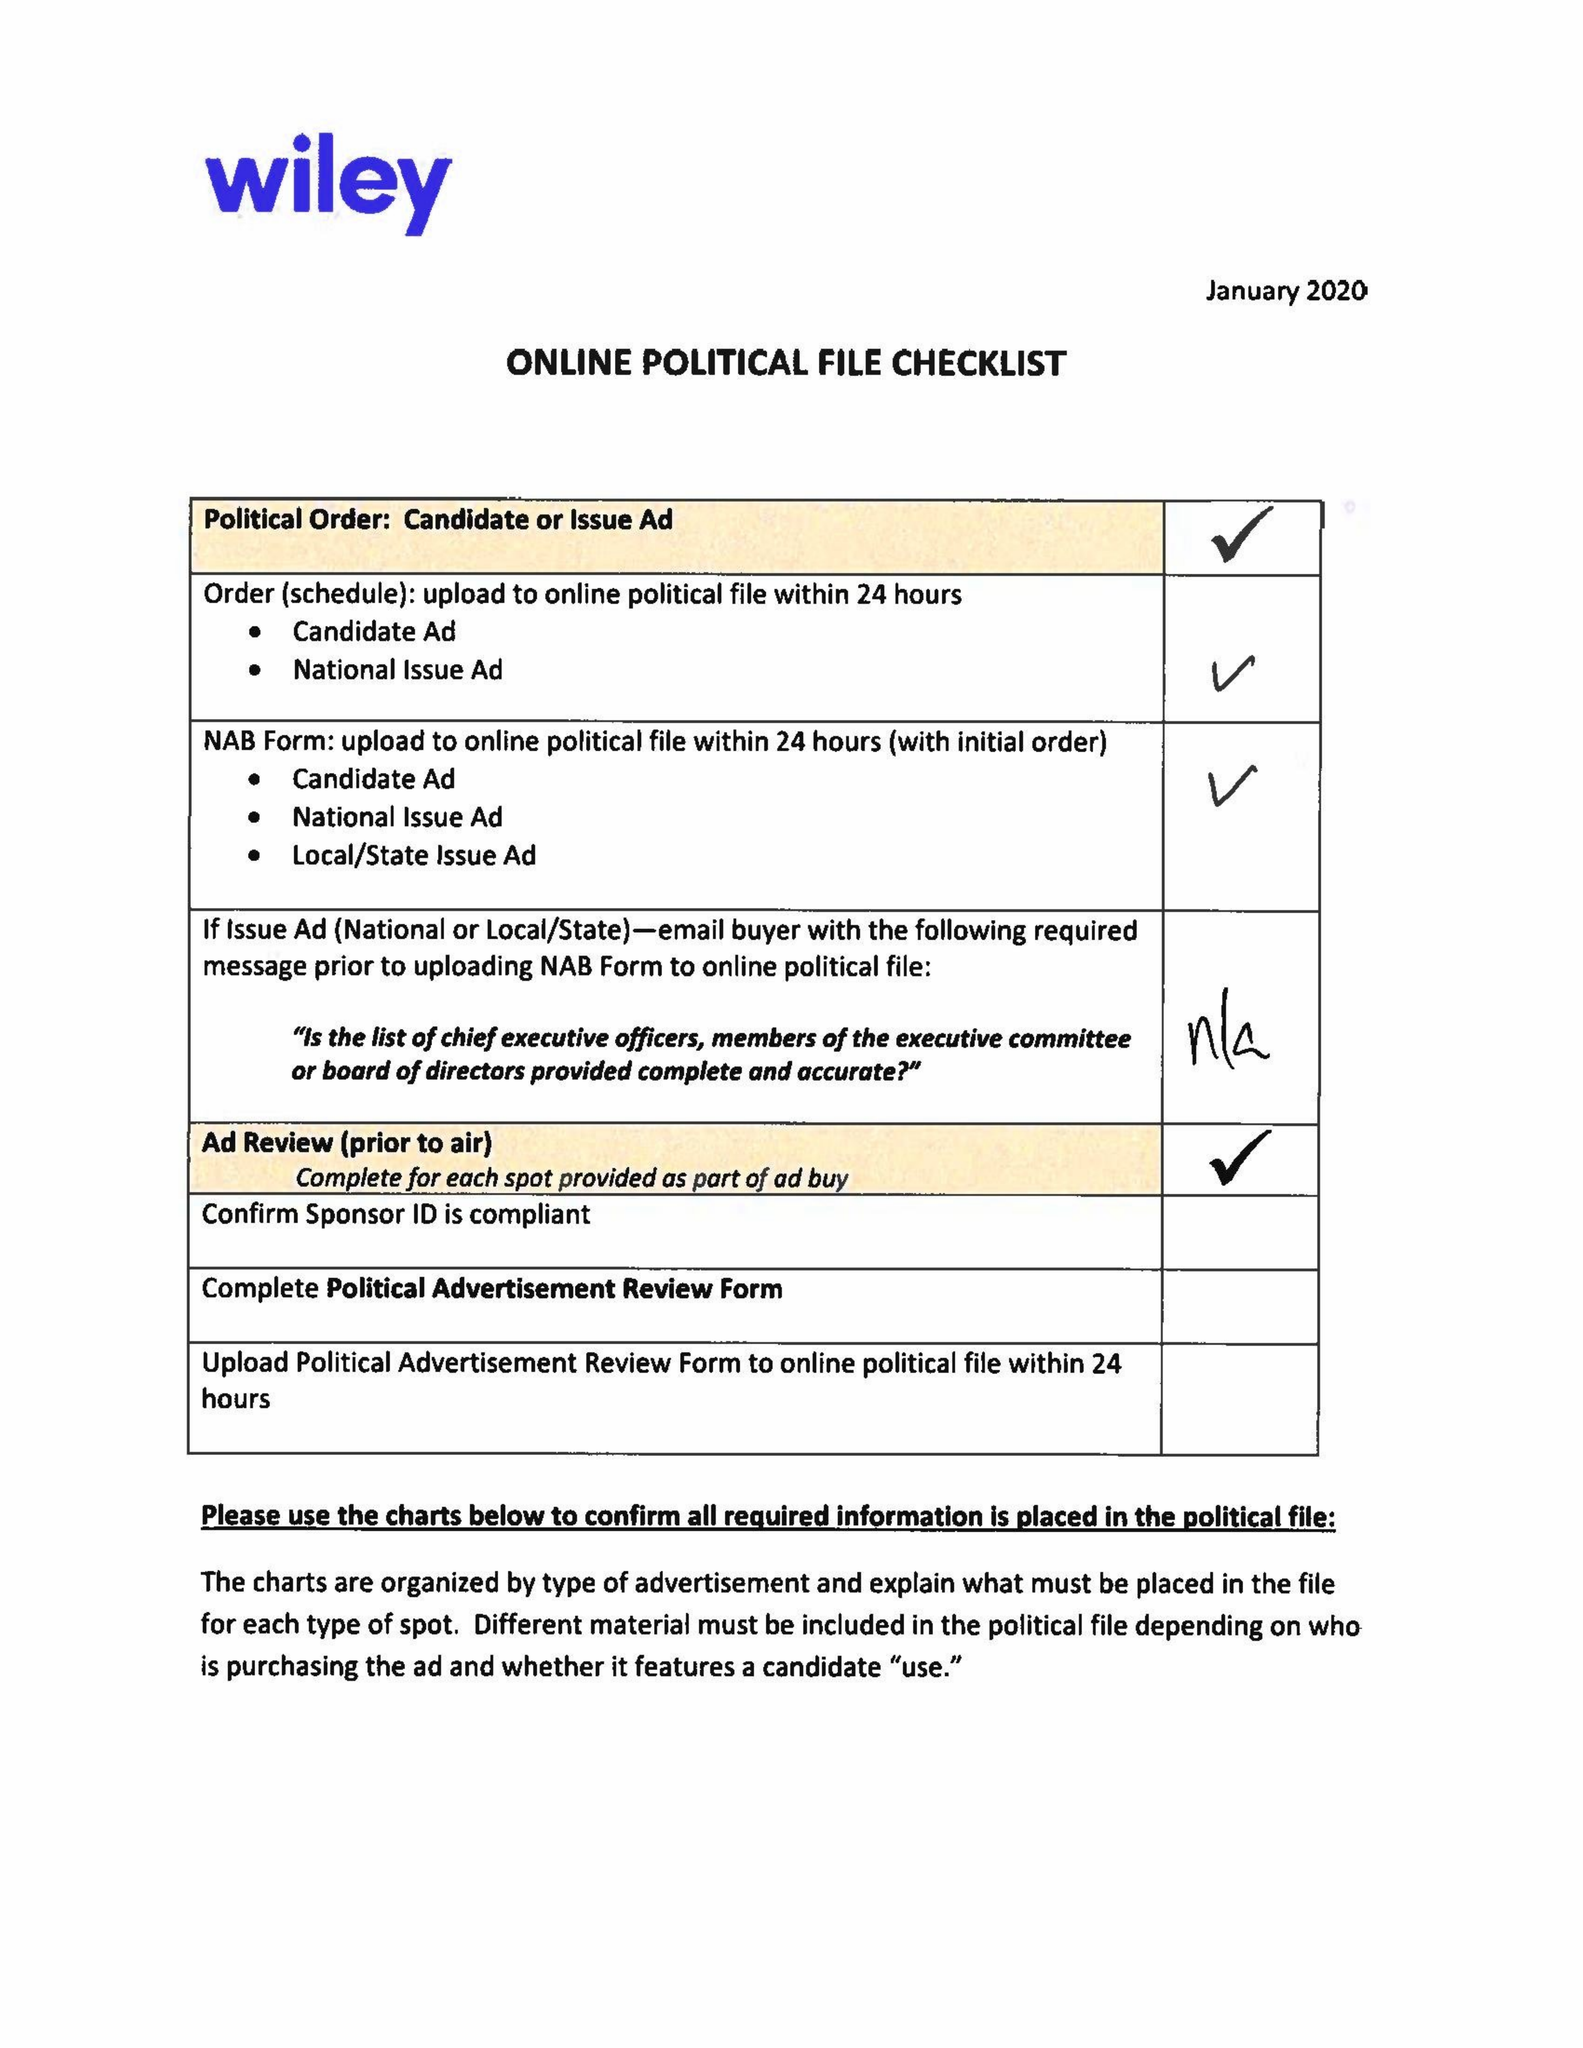What is the value for the gross_amount?
Answer the question using a single word or phrase. 17760.00 